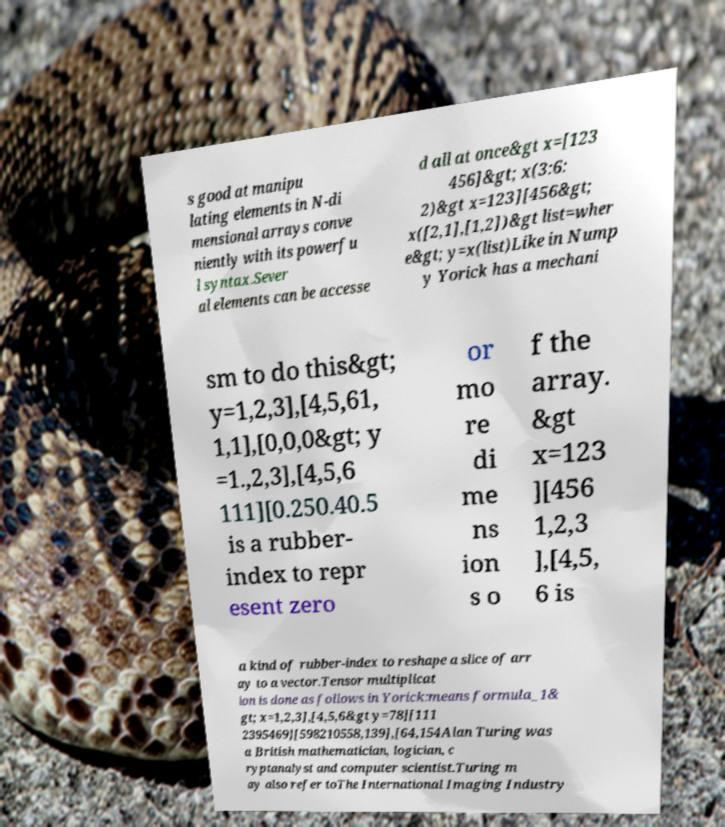Can you read and provide the text displayed in the image?This photo seems to have some interesting text. Can you extract and type it out for me? s good at manipu lating elements in N-di mensional arrays conve niently with its powerfu l syntax.Sever al elements can be accesse d all at once&gt x=[123 456]&gt; x(3:6: 2)&gt x=123][456&gt; x([2,1],[1,2])&gt list=wher e&gt; y=x(list)Like in Nump y Yorick has a mechani sm to do this&gt; y=1,2,3],[4,5,61, 1,1],[0,0,0&gt; y =1.,2,3],[4,5,6 111][0.250.40.5 is a rubber- index to repr esent zero or mo re di me ns ion s o f the array. &gt x=123 ][456 1,2,3 ],[4,5, 6 is a kind of rubber-index to reshape a slice of arr ay to a vector.Tensor multiplicat ion is done as follows in Yorick:means formula_1& gt; x=1,2,3],[4,5,6&gt y=78][111 2395469][598210558,139],[64,154Alan Turing was a British mathematician, logician, c ryptanalyst and computer scientist.Turing m ay also refer toThe International Imaging Industry 